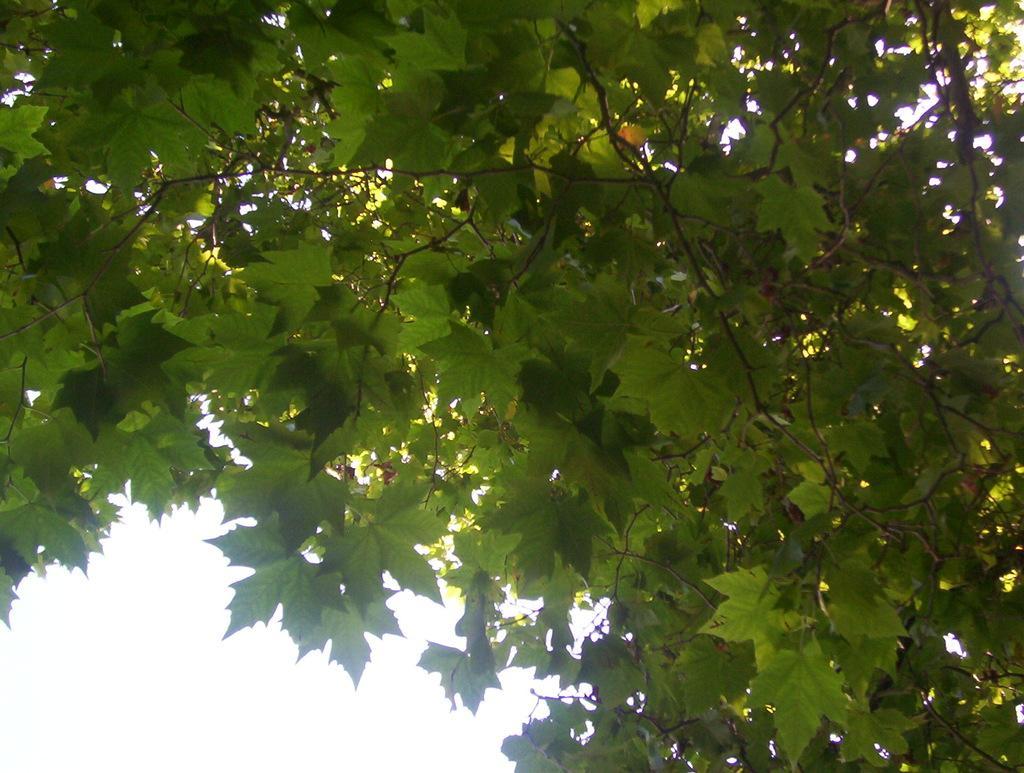Please provide a concise description of this image. In this image we can see a tree with leaves and stems. At the bottom of the image there is sky. 